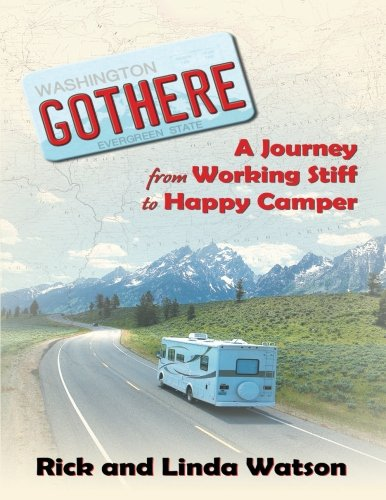Is this a journey related book? Yes, this book is related to journeys, particularly focusing on travel and exploring new locations, as the imagery and title suggest a personal travel experience. 